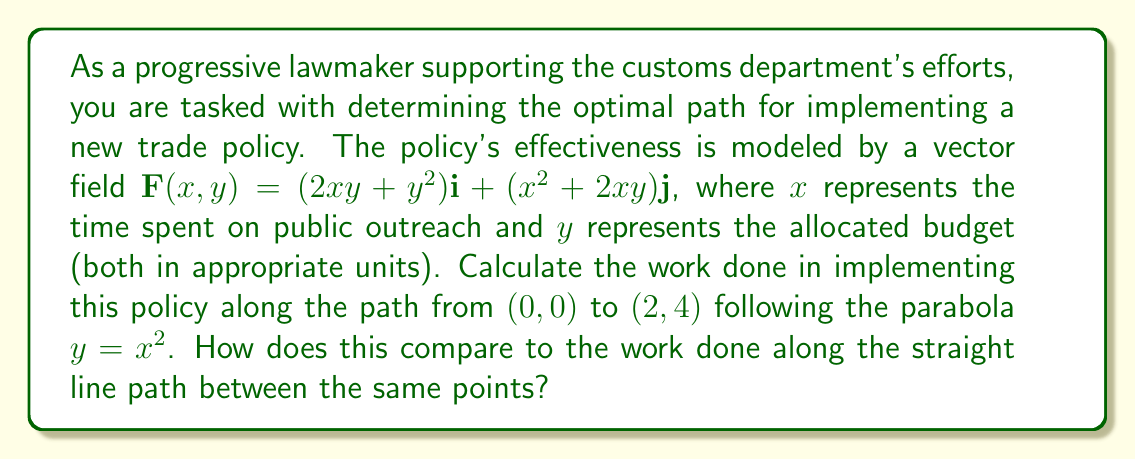Help me with this question. To solve this problem, we need to calculate line integrals along two different paths:

1. The parabolic path: $y = x^2$ from $(0,0)$ to $(2,4)$
2. The straight line path from $(0,0)$ to $(2,4)$

For the parabolic path:

1. Parametrize the path: $x = t$, $y = t^2$, $0 \leq t \leq 2$
2. Calculate $\frac{dx}{dt} = 1$ and $\frac{dy}{dt} = 2t$
3. The line integral is:

   $$\int_C \mathbf{F} \cdot d\mathbf{r} = \int_0^2 [(2xy + y^2)\frac{dx}{dt} + (x^2 + 2xy)\frac{dy}{dt}] dt$$

   $$= \int_0^2 [(2t \cdot t^2 + t^4) \cdot 1 + (t^2 + 2t \cdot t^2) \cdot 2t] dt$$

   $$= \int_0^2 (2t^3 + t^4 + 2t^3 + 4t^4) dt$$

   $$= \int_0^2 (4t^3 + 5t^4) dt$$

   $$= [t^4 + t^5]_0^2 = 16 + 32 = 48$$

For the straight line path:

1. Parametrize the path: $x = 2t$, $y = 4t$, $0 \leq t \leq 1$
2. Calculate $\frac{dx}{dt} = 2$ and $\frac{dy}{dt} = 4$
3. The line integral is:

   $$\int_C \mathbf{F} \cdot d\mathbf{r} = \int_0^1 [(2xy + y^2)\frac{dx}{dt} + (x^2 + 2xy)\frac{dy}{dt}] dt$$

   $$= \int_0^1 [(2(2t)(4t) + (4t)^2) \cdot 2 + ((2t)^2 + 2(2t)(4t)) \cdot 4] dt$$

   $$= \int_0^1 (32t^2 + 32t^2 + 16t^2 + 64t^2) dt$$

   $$= \int_0^1 144t^2 dt$$

   $$= [48t^3]_0^1 = 48$$

The work done along both paths is the same, which is 48 units. This is because the vector field $\mathbf{F}(x,y)$ is a conservative field, as can be verified by checking that $\frac{\partial}{\partial y}(2xy + y^2) = \frac{\partial}{\partial x}(x^2 + 2xy) = 2x + 2y$.
Answer: The work done along both the parabolic path and the straight line path is 48 units. The optimal path for policy implementation is independent of the chosen path between the start and end points, as the vector field is conservative. 